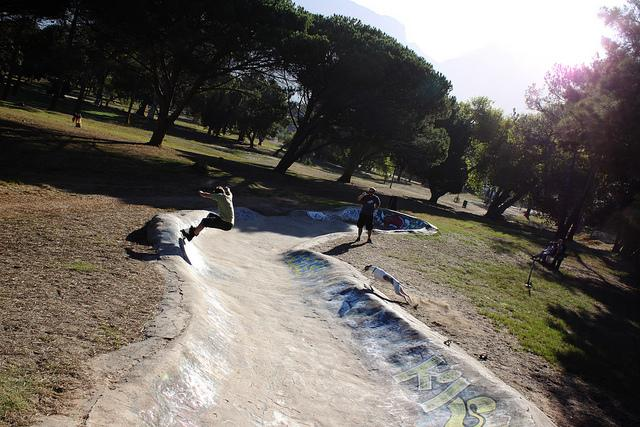Which person could be attacked by the dog first? green shirt 